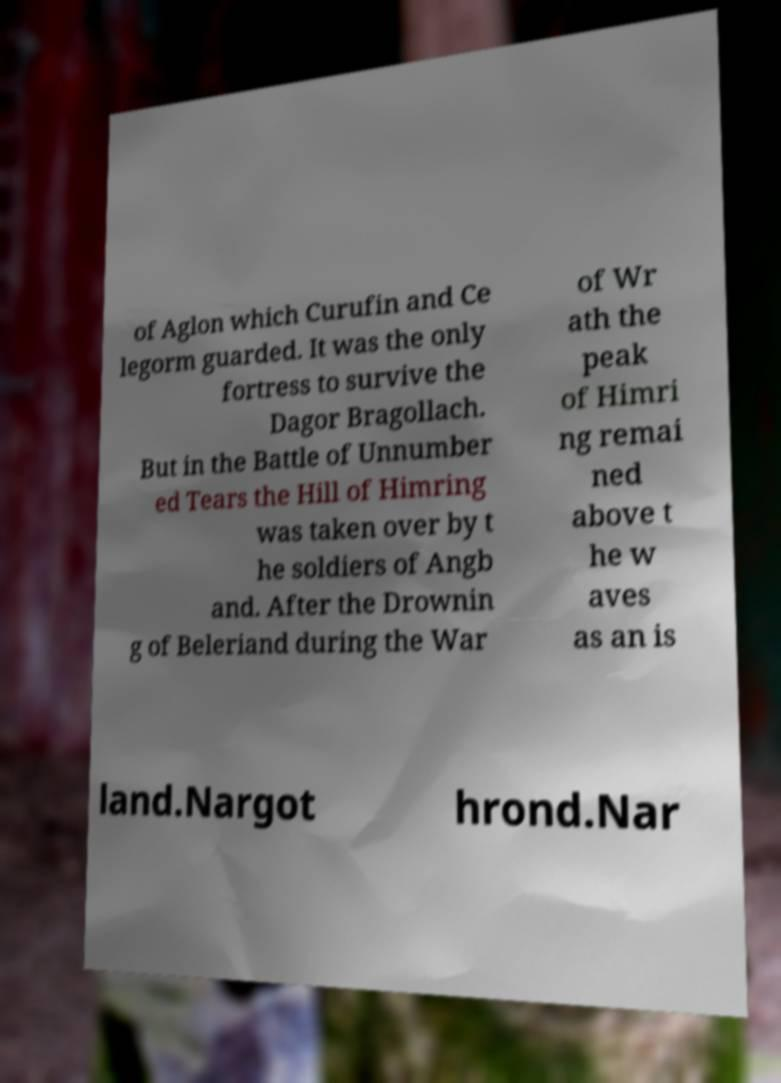Could you assist in decoding the text presented in this image and type it out clearly? of Aglon which Curufin and Ce legorm guarded. It was the only fortress to survive the Dagor Bragollach. But in the Battle of Unnumber ed Tears the Hill of Himring was taken over by t he soldiers of Angb and. After the Drownin g of Beleriand during the War of Wr ath the peak of Himri ng remai ned above t he w aves as an is land.Nargot hrond.Nar 